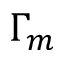<formula> <loc_0><loc_0><loc_500><loc_500>\Gamma _ { m }</formula> 